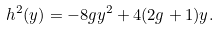<formula> <loc_0><loc_0><loc_500><loc_500>h ^ { 2 } ( y ) = - 8 g y ^ { 2 } + 4 ( 2 g + 1 ) y .</formula> 